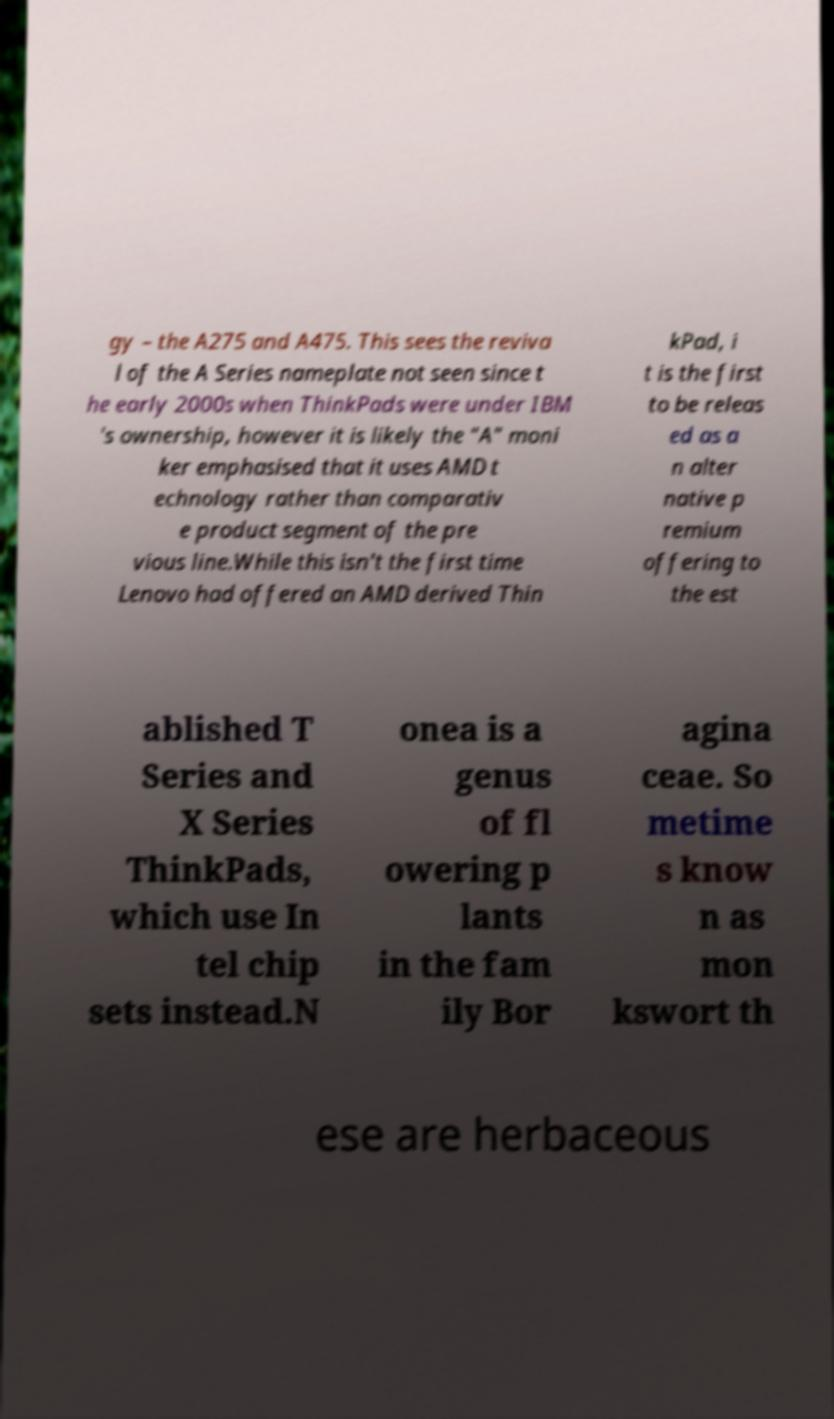For documentation purposes, I need the text within this image transcribed. Could you provide that? gy – the A275 and A475. This sees the reviva l of the A Series nameplate not seen since t he early 2000s when ThinkPads were under IBM 's ownership, however it is likely the "A" moni ker emphasised that it uses AMD t echnology rather than comparativ e product segment of the pre vious line.While this isn't the first time Lenovo had offered an AMD derived Thin kPad, i t is the first to be releas ed as a n alter native p remium offering to the est ablished T Series and X Series ThinkPads, which use In tel chip sets instead.N onea is a genus of fl owering p lants in the fam ily Bor agina ceae. So metime s know n as mon kswort th ese are herbaceous 